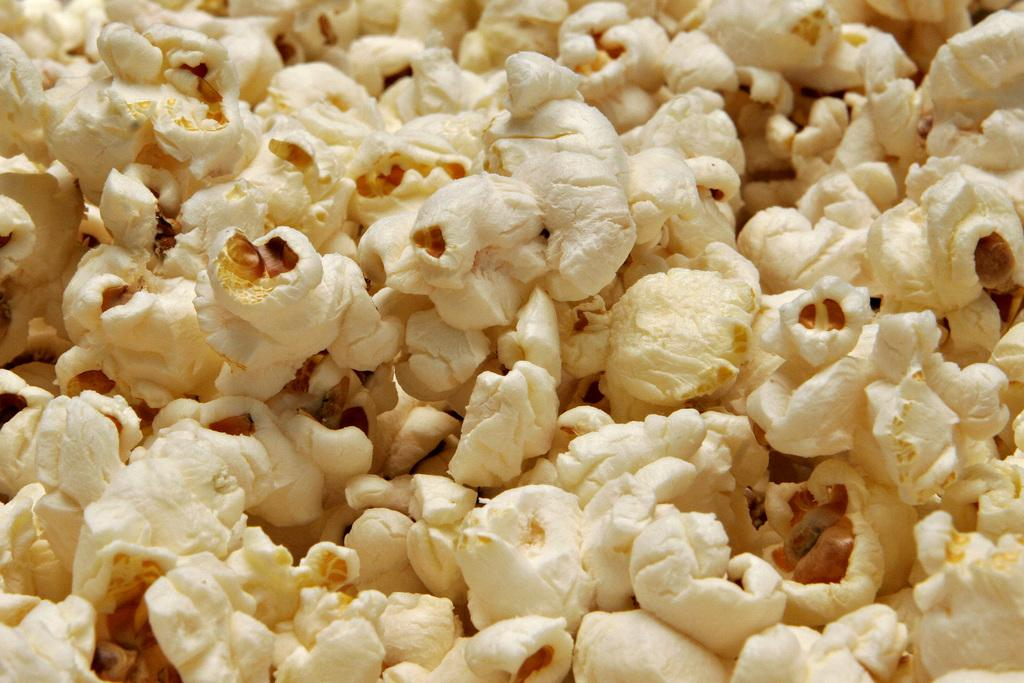What is the main subject of the image? The main subject of the image is popcorn. Can you describe the popcorn in the image? The image is a zoom-in picture of popcorn, so it shows a close-up view of the popcorn. Who is the expert volleyball player in the image? There is no expert volleyball player or any reference to volleyball in the image; it is a zoom-in picture of popcorn. 